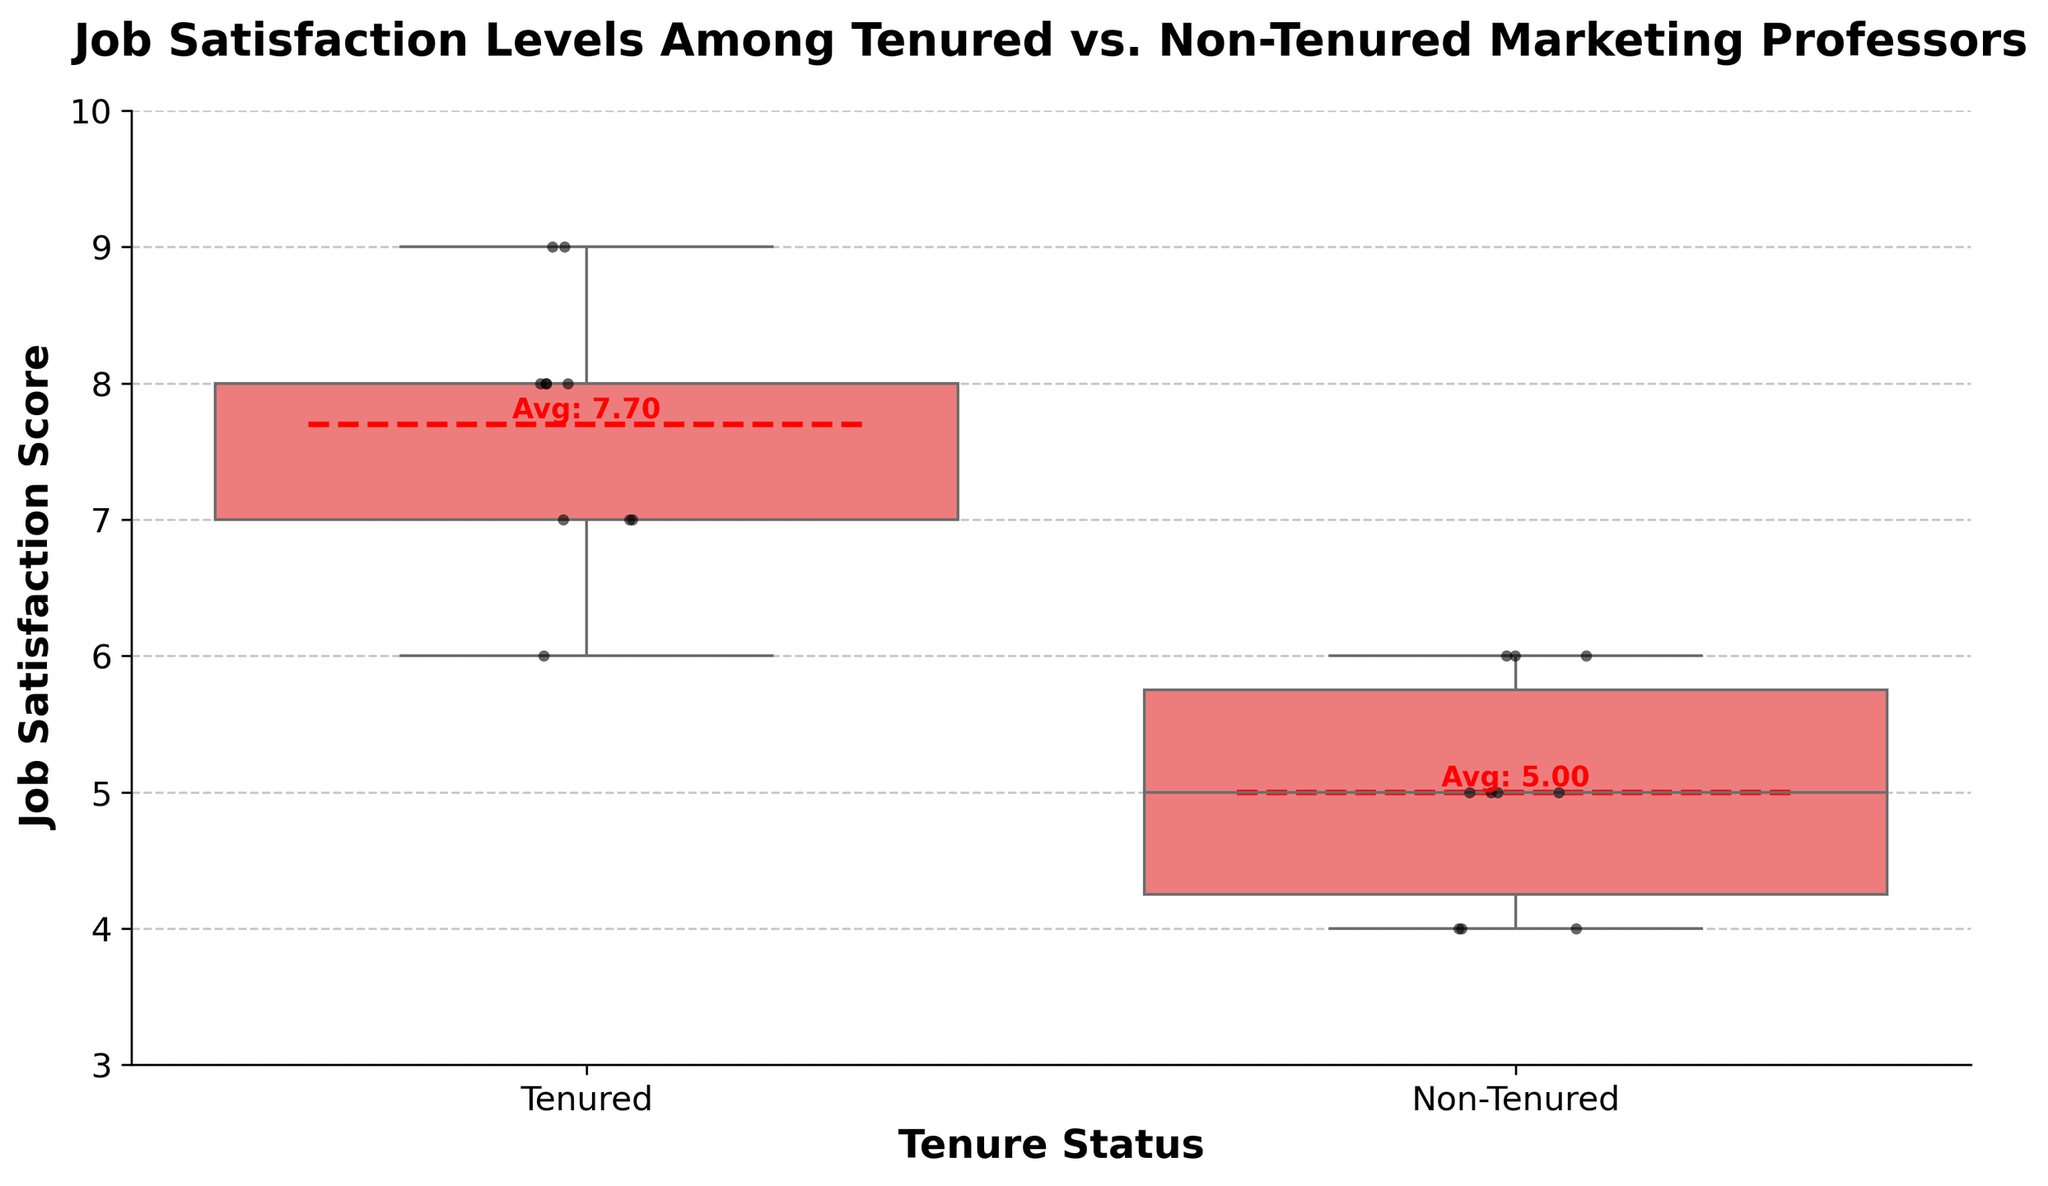What's the title of the figure? The title is at the top of the figure and reads 'Job Satisfaction Levels Among Tenured vs. Non-Tenured Marketing Professors'.
Answer: Job Satisfaction Levels Among Tenured vs. Non-Tenured Marketing Professors What are the groups compared in the figure? The figure compares two groups, as labeled on the x-axis: 'Tenured' and 'Non-Tenured'.
Answer: Tenured and Non-Tenured What is the range of the y-axis? The y-axis is labeled 'Job Satisfaction Score' and the range is from 3 to 10.
Answer: 3 to 10 How many individual data points are there for each group? The data points are visible as individual dots on the plot. Counting them shows 10 points for each group.
Answer: 10 for each group Which group has a higher average job satisfaction score? The average job satisfaction score is indicated by the red dashed line and text in the middle of each box. The Tenured group shows an average of around 7.7, while the Non-Tenured group shows around 5.0. Therefore, the Tenured group has a higher average.
Answer: Tenured What is the median job satisfaction score for the Tenured group? The median is represented by the line inside the box of the box plot. For the Tenured group, this line is at 8.
Answer: 8 How does the spread of job satisfaction scores compare between the two groups? The interquartile range (IQR) is represented by the height of the box. The Tenured group has a smaller IQR (6 to 9) compared to the Non-Tenured group (4 to 6), indicating that the Tenured group's scores are less spread out.
Answer: Smaller for Tenured What is the difference in the average job satisfaction scores between the Tenured and Non-Tenured groups? The average scores are given as 7.7 for Tenured and 5.0 for Non-Tenured. The difference is calculated as 7.7 - 5.0 = 2.7.
Answer: 2.7 What job satisfaction score appears most frequently in the Non-Tenured group? From the strip plot, the most frequent score can be seen with the highest density of points. For the Non-Tenured group, the score 5 appears most frequently.
Answer: 5 